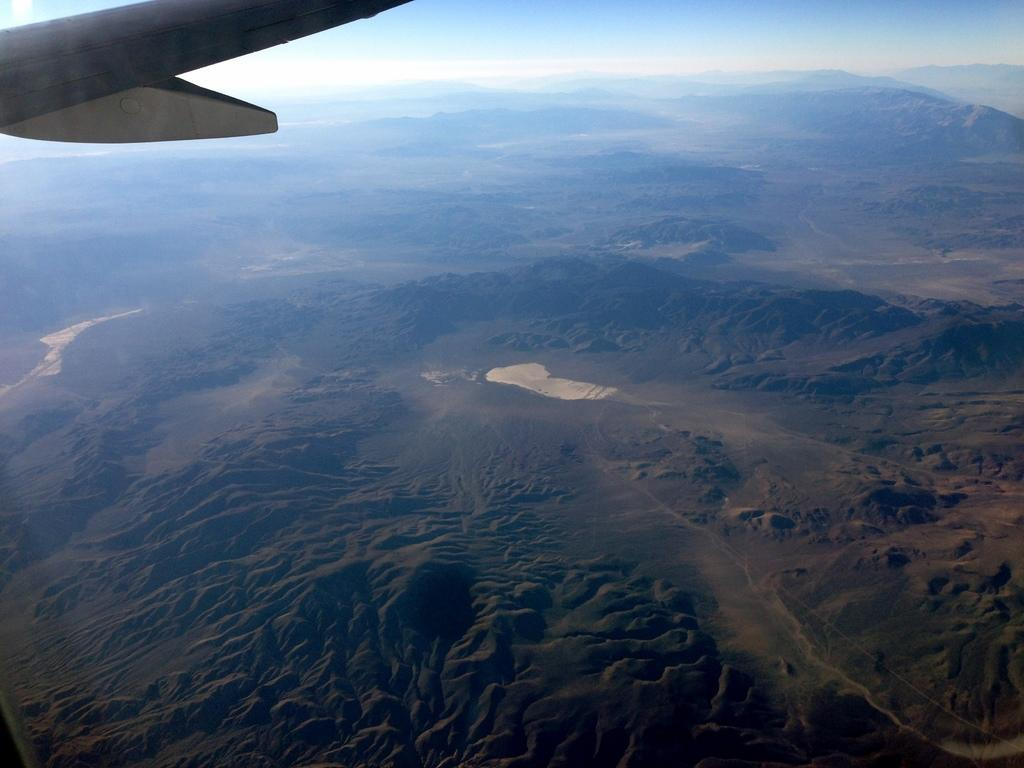What is the vantage point of the image? The image is taken from a plane window. What part of the plane can be seen in the image? The plane wing is visible in the image. What type of landscape is visible in the image? There are hills visible in the image. How many kittens are playing with the wealth in the image? There are no kittens or wealth present in the image; it is a view from a plane window with a visible plane wing and hills. 